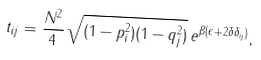Convert formula to latex. <formula><loc_0><loc_0><loc_500><loc_500>t _ { i j } = \frac { N ^ { 2 } } { 4 } \, \sqrt { ( 1 - p _ { i } ^ { 2 } ) ( 1 - q _ { j } ^ { 2 } ) } \, e ^ { \beta ( \epsilon + 2 \delta \delta _ { i j } ) } ,</formula> 